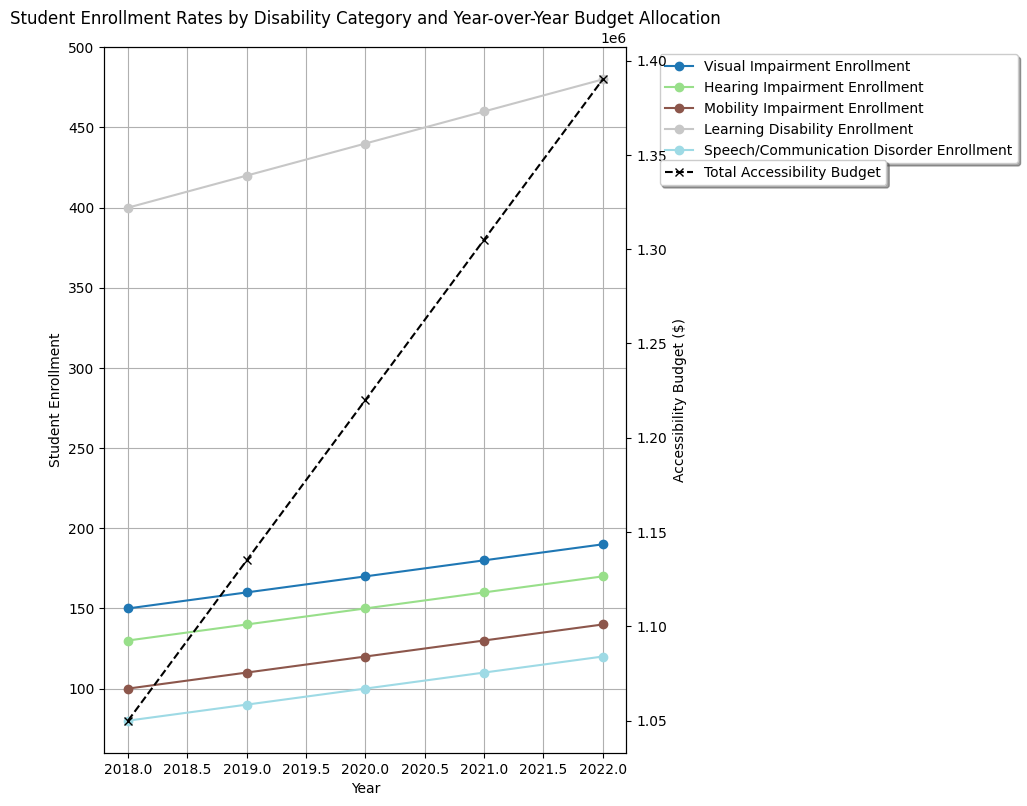What is the trend in student enrollment for Visual Impairment from 2018 to 2022? To determine the trend, look at the plot lines corresponding to Visual Impairment enrollment on the primary axis. From 2018 to 2022, the data points for Visual Impairment enrollment are increasing consistently, indicating an upward trend.
Answer: Upward trend Which disability category had the highest enrollment in 2022? To answer this, identify the category with the highest data point on the primary axis in 2022. The data shows that Learning Disability had the highest enrollment in 2022.
Answer: Learning Disability By how much did the total accessibility budget increase from 2018 to 2022? From the secondary axis representing budget, note the budget amounts for 2018 and 2022, which are $1,050,000 and $1,310,000 respectively. Subtract the 2018 budget from the 2022 budget: $1,310,000 - $1,050,000 = $260,000.
Answer: $260,000 What is the average enrollment across all disability categories for the year 2020? Look at the enrollment values for each disability category in 2020 on the primary axis: Visual Impairment (170), Hearing Impairment (150), Mobility Impairment (120), Learning Disability (440), Speech/Communication Disorder (100). Sum these values and divide by 5: (170 + 150 + 120 + 440 + 100)/5 = 980/5 = 196.
Answer: 196 Which year saw the highest total accessibility budget allocated? Check the plots on the secondary axis for each year. The year with the highest total accessibility budget is 2022, with a budget of $1,310,000.
Answer: 2022 How does the enrollment trend for Learning Disability compare to that of Mobility Impairment from 2018 to 2022? To compare trends, examine the plot lines for Learning Disability and Mobility Impairment. The enrollment for Learning Disability shows a consistent upward trend, while Mobility Impairment also shows an upward trend, but at a slower rate.
Answer: Both have upward trends; Learning Disability increases faster In which year did the budget increase the most compared to the previous year? To find the year with the highest budget increase, calculate the yearly differences from the secondary axis: 2019 ($1,135,000 - $1,050,000 = $85,000), 2020 ($1,220,000 - $1,135,000 = $85,000), 2021 ($1,305,000 - $1,220,000 = $85,000), 2022 ($1,310,000 - $1,305,000 = $5,000). All annual increases are the same with $85,000, except for 2022, which is $5,000.
Answer: 2019, 2020, and 2021 What is the overall trend of the total accessibility budget from 2018 to 2022? Assessing the data points from 2018 to 2022 on the secondary axis, it is evident that the budget has a consistent upward trend each year.
Answer: Upward trend Which disability category had the smallest increase in enrollment from 2018 to 2022? List the starting and ending enrollments for each category: Visual Impairment (150 to 190), Hearing Impairment (130 to 170), Mobility Impairment (100 to 140), Learning Disability (400 to 480), Speech/Communication Disorder (80 to 120). Calculate the differences: Visual Impairment (40), Hearing Impairment (40), Mobility Impairment (40), Learning Disability (80), Speech/Communication Disorder (40). All had the smallest increase of 40, except Learning Disability, which increased by 80.
Answer: Speech/Communication Disorder, Visual Impairment, Hearing Impairment, Mobility Impairment 